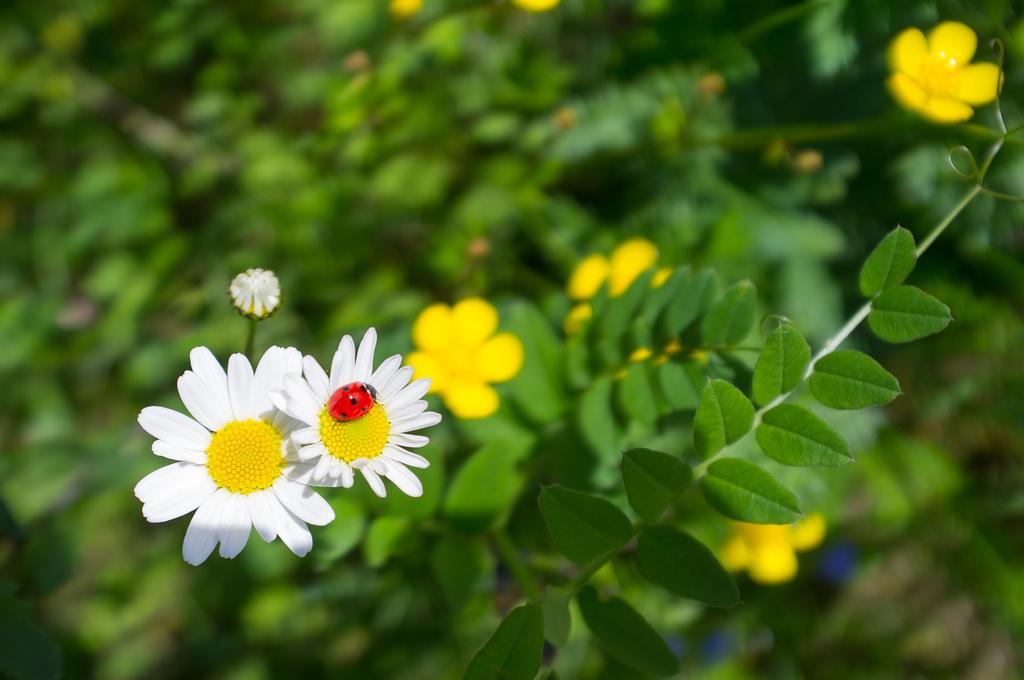Could you give a brief overview of what you see in this image? This image consists of a plant. It has flowers. On one flower there is a bug. 